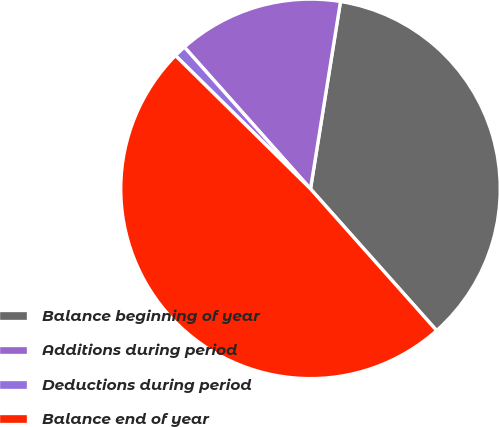Convert chart. <chart><loc_0><loc_0><loc_500><loc_500><pie_chart><fcel>Balance beginning of year<fcel>Additions during period<fcel>Deductions during period<fcel>Balance end of year<nl><fcel>35.9%<fcel>14.1%<fcel>1.03%<fcel>48.97%<nl></chart> 